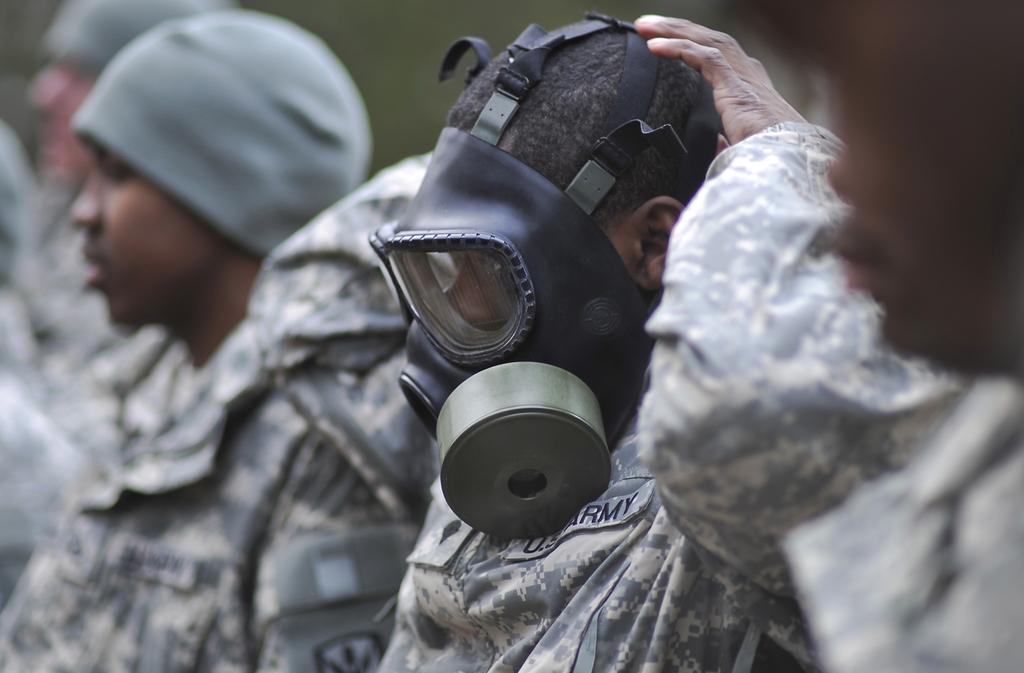What are the people in the image wearing on their heads? The people in the image are wearing head-wear. Can you describe the background of the image? The background of the image is blurred. What type of hose is being used by the people in the image? There is no hose present in the image; the people are wearing head-wear. What shape is the dog in the image? There is no dog present in the image. 